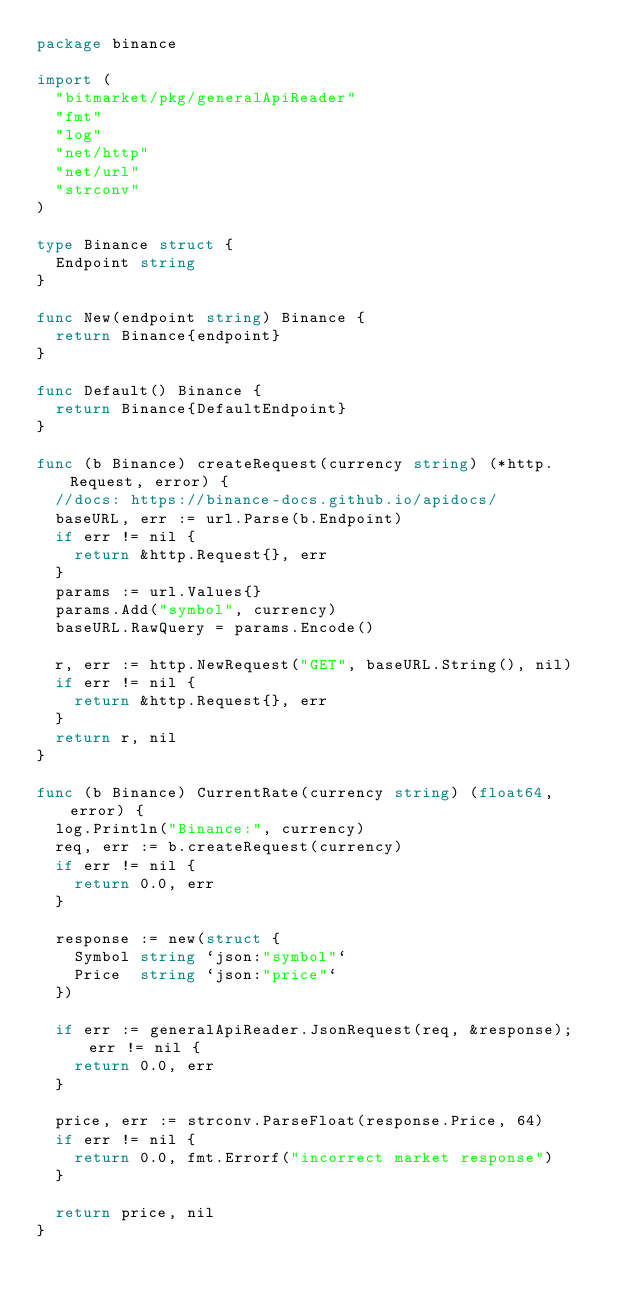Convert code to text. <code><loc_0><loc_0><loc_500><loc_500><_Go_>package binance

import (
	"bitmarket/pkg/generalApiReader"
	"fmt"
	"log"
	"net/http"
	"net/url"
	"strconv"
)

type Binance struct {
	Endpoint string
}

func New(endpoint string) Binance {
	return Binance{endpoint}
}

func Default() Binance {
	return Binance{DefaultEndpoint}
}

func (b Binance) createRequest(currency string) (*http.Request, error) {
	//docs: https://binance-docs.github.io/apidocs/
	baseURL, err := url.Parse(b.Endpoint)
	if err != nil {
		return &http.Request{}, err
	}
	params := url.Values{}
	params.Add("symbol", currency)
	baseURL.RawQuery = params.Encode()

	r, err := http.NewRequest("GET", baseURL.String(), nil)
	if err != nil {
		return &http.Request{}, err
	}
	return r, nil
}

func (b Binance) CurrentRate(currency string) (float64, error) {
	log.Println("Binance:", currency)
	req, err := b.createRequest(currency)
	if err != nil {
		return 0.0, err
	}

	response := new(struct {
		Symbol string `json:"symbol"`
		Price  string `json:"price"`
	})

	if err := generalApiReader.JsonRequest(req, &response); err != nil {
		return 0.0, err
	}

	price, err := strconv.ParseFloat(response.Price, 64)
	if err != nil {
		return 0.0, fmt.Errorf("incorrect market response")
	}

	return price, nil
}
</code> 